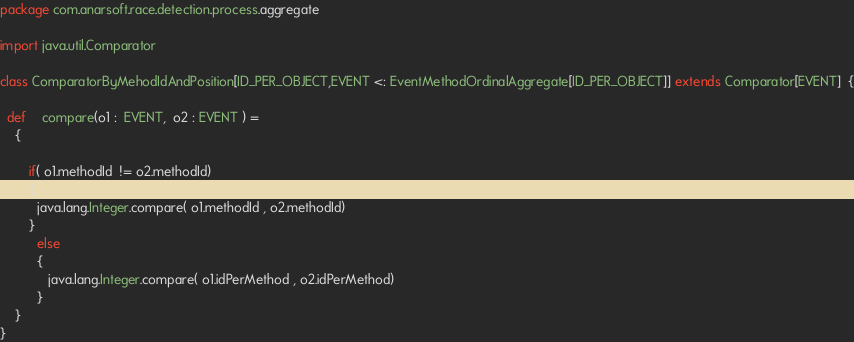<code> <loc_0><loc_0><loc_500><loc_500><_Scala_>package com.anarsoft.race.detection.process.aggregate

import java.util.Comparator

class ComparatorByMehodIdAndPosition[ID_PER_OBJECT,EVENT <: EventMethodOrdinalAggregate[ID_PER_OBJECT]] extends Comparator[EVENT]  {
 
  def	compare(o1 :  EVENT,  o2 : EVENT ) =
    {
       
        if( o1.methodId  != o2.methodId)
        {
          java.lang.Integer.compare( o1.methodId , o2.methodId)
        }
          else
          {
             java.lang.Integer.compare( o1.idPerMethod , o2.idPerMethod)
          }
    }  
}</code> 